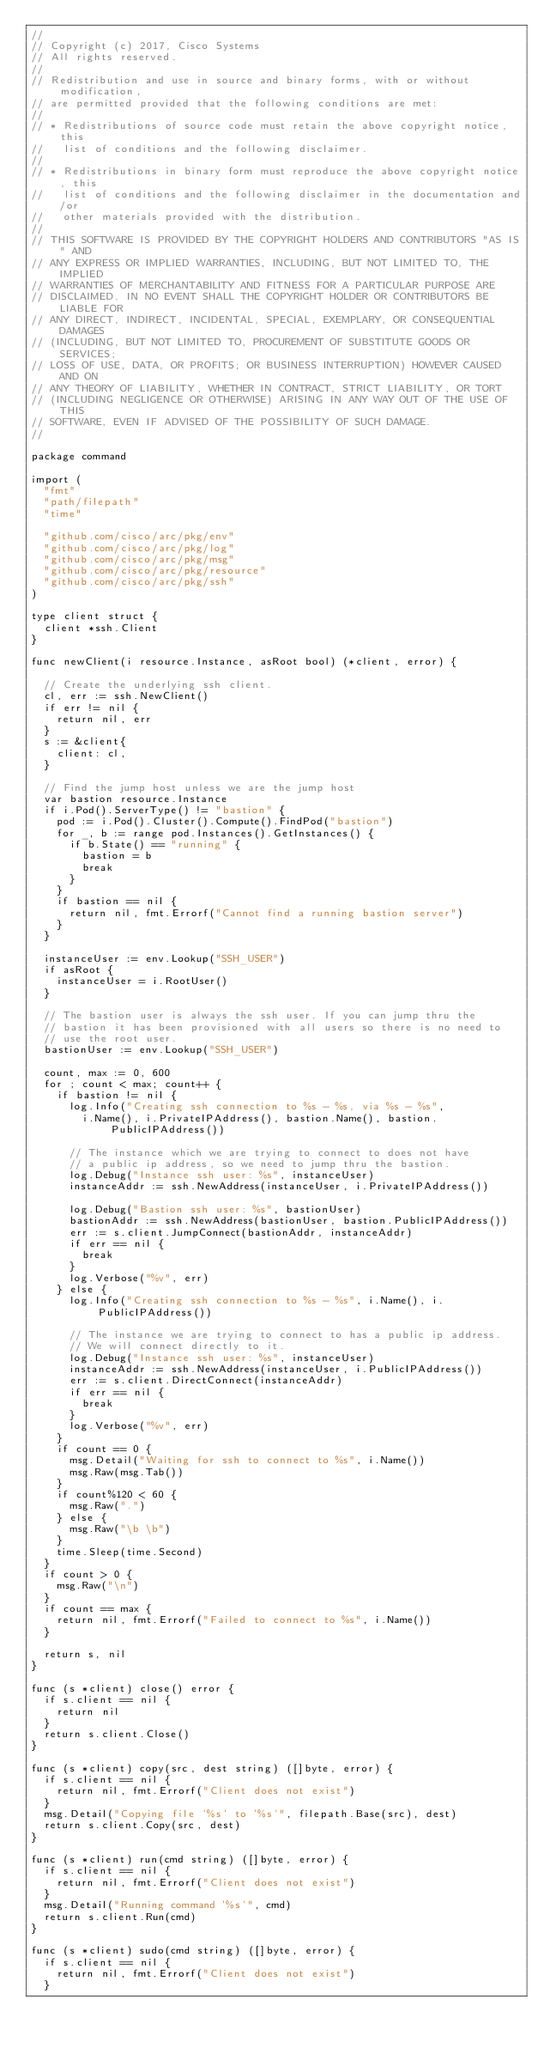Convert code to text. <code><loc_0><loc_0><loc_500><loc_500><_Go_>//
// Copyright (c) 2017, Cisco Systems
// All rights reserved.
//
// Redistribution and use in source and binary forms, with or without modification,
// are permitted provided that the following conditions are met:
//
// * Redistributions of source code must retain the above copyright notice, this
//   list of conditions and the following disclaimer.
//
// * Redistributions in binary form must reproduce the above copyright notice, this
//   list of conditions and the following disclaimer in the documentation and/or
//   other materials provided with the distribution.
//
// THIS SOFTWARE IS PROVIDED BY THE COPYRIGHT HOLDERS AND CONTRIBUTORS "AS IS" AND
// ANY EXPRESS OR IMPLIED WARRANTIES, INCLUDING, BUT NOT LIMITED TO, THE IMPLIED
// WARRANTIES OF MERCHANTABILITY AND FITNESS FOR A PARTICULAR PURPOSE ARE
// DISCLAIMED. IN NO EVENT SHALL THE COPYRIGHT HOLDER OR CONTRIBUTORS BE LIABLE FOR
// ANY DIRECT, INDIRECT, INCIDENTAL, SPECIAL, EXEMPLARY, OR CONSEQUENTIAL DAMAGES
// (INCLUDING, BUT NOT LIMITED TO, PROCUREMENT OF SUBSTITUTE GOODS OR SERVICES;
// LOSS OF USE, DATA, OR PROFITS; OR BUSINESS INTERRUPTION) HOWEVER CAUSED AND ON
// ANY THEORY OF LIABILITY, WHETHER IN CONTRACT, STRICT LIABILITY, OR TORT
// (INCLUDING NEGLIGENCE OR OTHERWISE) ARISING IN ANY WAY OUT OF THE USE OF THIS
// SOFTWARE, EVEN IF ADVISED OF THE POSSIBILITY OF SUCH DAMAGE.
//

package command

import (
	"fmt"
	"path/filepath"
	"time"

	"github.com/cisco/arc/pkg/env"
	"github.com/cisco/arc/pkg/log"
	"github.com/cisco/arc/pkg/msg"
	"github.com/cisco/arc/pkg/resource"
	"github.com/cisco/arc/pkg/ssh"
)

type client struct {
	client *ssh.Client
}

func newClient(i resource.Instance, asRoot bool) (*client, error) {

	// Create the underlying ssh client.
	cl, err := ssh.NewClient()
	if err != nil {
		return nil, err
	}
	s := &client{
		client: cl,
	}

	// Find the jump host unless we are the jump host
	var bastion resource.Instance
	if i.Pod().ServerType() != "bastion" {
		pod := i.Pod().Cluster().Compute().FindPod("bastion")
		for _, b := range pod.Instances().GetInstances() {
			if b.State() == "running" {
				bastion = b
				break
			}
		}
		if bastion == nil {
			return nil, fmt.Errorf("Cannot find a running bastion server")
		}
	}

	instanceUser := env.Lookup("SSH_USER")
	if asRoot {
		instanceUser = i.RootUser()
	}

	// The bastion user is always the ssh user. If you can jump thru the
	// bastion it has been provisioned with all users so there is no need to
	// use the root user.
	bastionUser := env.Lookup("SSH_USER")

	count, max := 0, 600
	for ; count < max; count++ {
		if bastion != nil {
			log.Info("Creating ssh connection to %s - %s, via %s - %s",
				i.Name(), i.PrivateIPAddress(), bastion.Name(), bastion.PublicIPAddress())

			// The instance which we are trying to connect to does not have
			// a public ip address, so we need to jump thru the bastion.
			log.Debug("Instance ssh user: %s", instanceUser)
			instanceAddr := ssh.NewAddress(instanceUser, i.PrivateIPAddress())

			log.Debug("Bastion ssh user: %s", bastionUser)
			bastionAddr := ssh.NewAddress(bastionUser, bastion.PublicIPAddress())
			err := s.client.JumpConnect(bastionAddr, instanceAddr)
			if err == nil {
				break
			}
			log.Verbose("%v", err)
		} else {
			log.Info("Creating ssh connection to %s - %s", i.Name(), i.PublicIPAddress())

			// The instance we are trying to connect to has a public ip address.
			// We will connect directly to it.
			log.Debug("Instance ssh user: %s", instanceUser)
			instanceAddr := ssh.NewAddress(instanceUser, i.PublicIPAddress())
			err := s.client.DirectConnect(instanceAddr)
			if err == nil {
				break
			}
			log.Verbose("%v", err)
		}
		if count == 0 {
			msg.Detail("Waiting for ssh to connect to %s", i.Name())
			msg.Raw(msg.Tab())
		}
		if count%120 < 60 {
			msg.Raw(".")
		} else {
			msg.Raw("\b \b")
		}
		time.Sleep(time.Second)
	}
	if count > 0 {
		msg.Raw("\n")
	}
	if count == max {
		return nil, fmt.Errorf("Failed to connect to %s", i.Name())
	}

	return s, nil
}

func (s *client) close() error {
	if s.client == nil {
		return nil
	}
	return s.client.Close()
}

func (s *client) copy(src, dest string) ([]byte, error) {
	if s.client == nil {
		return nil, fmt.Errorf("Client does not exist")
	}
	msg.Detail("Copying file '%s' to '%s'", filepath.Base(src), dest)
	return s.client.Copy(src, dest)
}

func (s *client) run(cmd string) ([]byte, error) {
	if s.client == nil {
		return nil, fmt.Errorf("Client does not exist")
	}
	msg.Detail("Running command '%s'", cmd)
	return s.client.Run(cmd)
}

func (s *client) sudo(cmd string) ([]byte, error) {
	if s.client == nil {
		return nil, fmt.Errorf("Client does not exist")
	}</code> 